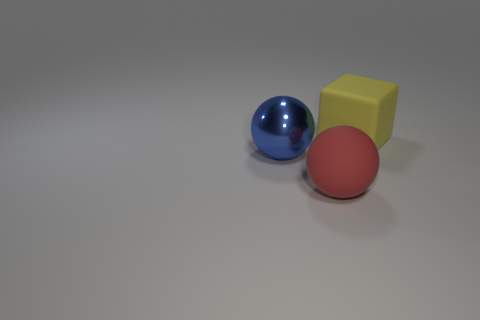Add 2 brown balls. How many objects exist? 5 Subtract all blue balls. How many balls are left? 1 Subtract 1 balls. How many balls are left? 1 Subtract all cyan balls. Subtract all gray cylinders. How many balls are left? 2 Subtract all red spheres. How many cyan blocks are left? 0 Subtract all rubber spheres. Subtract all blue metallic balls. How many objects are left? 1 Add 3 red spheres. How many red spheres are left? 4 Add 2 brown objects. How many brown objects exist? 2 Subtract 0 cyan spheres. How many objects are left? 3 Subtract all spheres. How many objects are left? 1 